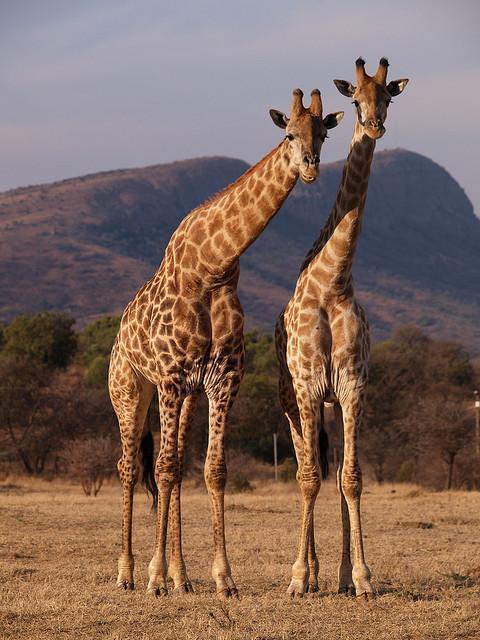How many animals are shown?
Give a very brief answer. 2. How many giraffes are looking at the camera?
Give a very brief answer. 2. How many giraffes are facing the camera?
Give a very brief answer. 2. How many giraffes?
Give a very brief answer. 2. How many giraffes are there?
Give a very brief answer. 2. How many people are looking at the white car?
Give a very brief answer. 0. 